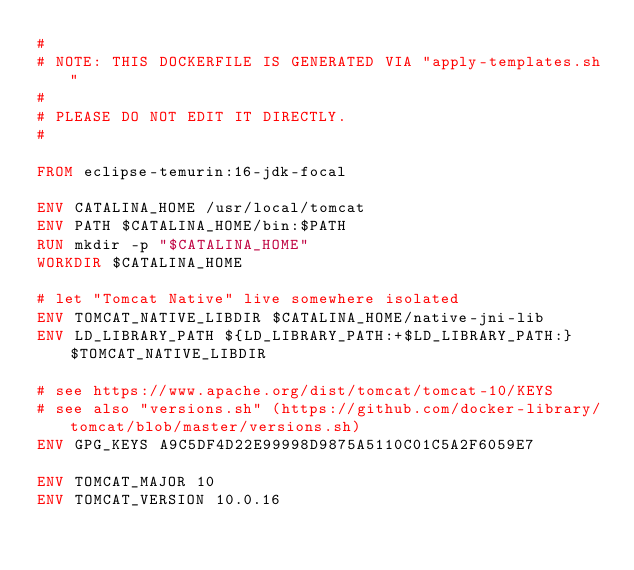Convert code to text. <code><loc_0><loc_0><loc_500><loc_500><_Dockerfile_>#
# NOTE: THIS DOCKERFILE IS GENERATED VIA "apply-templates.sh"
#
# PLEASE DO NOT EDIT IT DIRECTLY.
#

FROM eclipse-temurin:16-jdk-focal

ENV CATALINA_HOME /usr/local/tomcat
ENV PATH $CATALINA_HOME/bin:$PATH
RUN mkdir -p "$CATALINA_HOME"
WORKDIR $CATALINA_HOME

# let "Tomcat Native" live somewhere isolated
ENV TOMCAT_NATIVE_LIBDIR $CATALINA_HOME/native-jni-lib
ENV LD_LIBRARY_PATH ${LD_LIBRARY_PATH:+$LD_LIBRARY_PATH:}$TOMCAT_NATIVE_LIBDIR

# see https://www.apache.org/dist/tomcat/tomcat-10/KEYS
# see also "versions.sh" (https://github.com/docker-library/tomcat/blob/master/versions.sh)
ENV GPG_KEYS A9C5DF4D22E99998D9875A5110C01C5A2F6059E7

ENV TOMCAT_MAJOR 10
ENV TOMCAT_VERSION 10.0.16</code> 